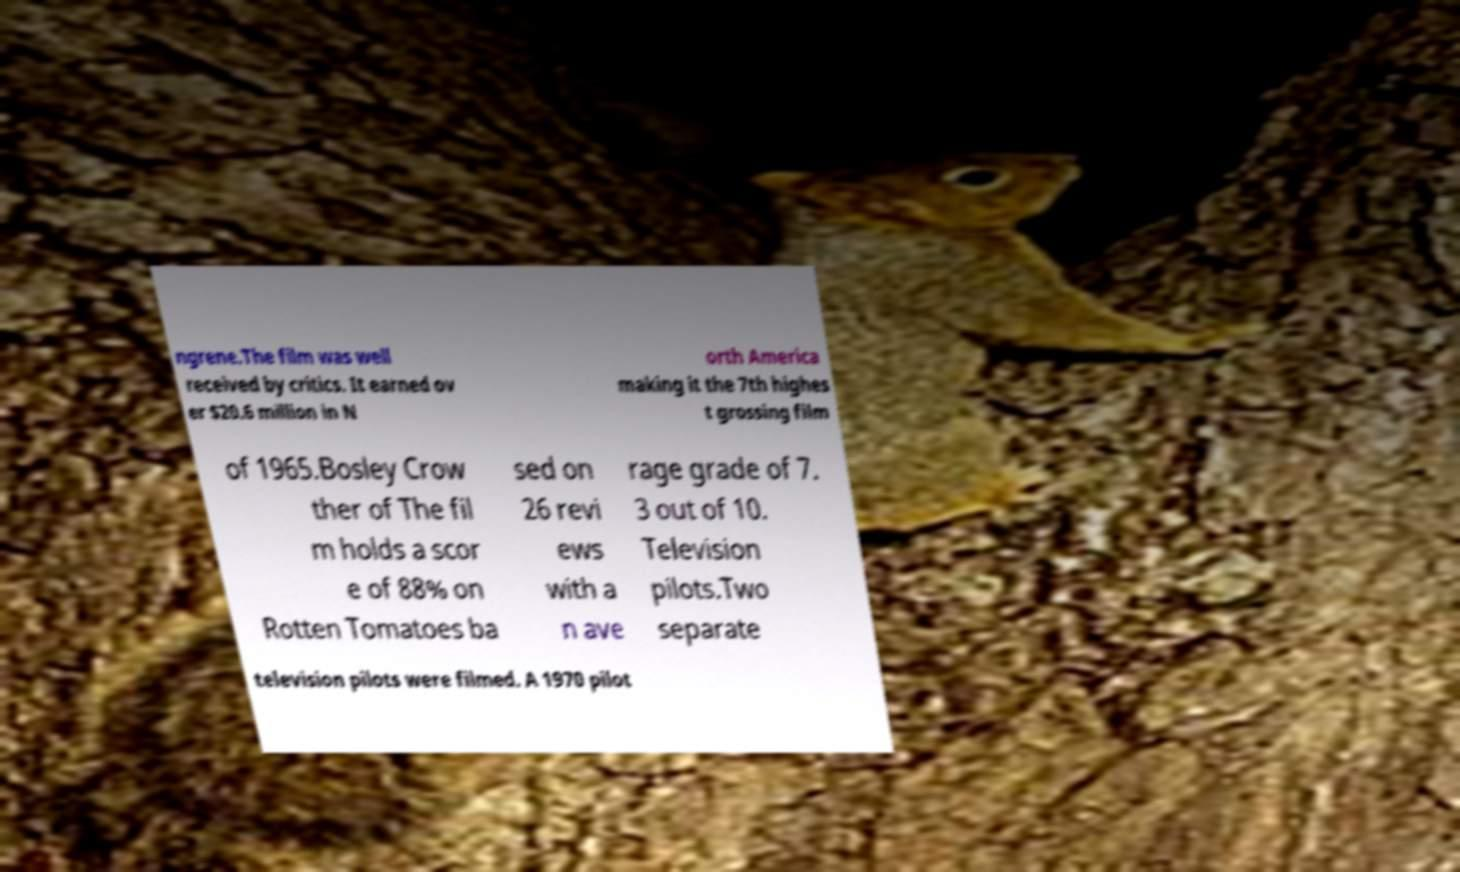There's text embedded in this image that I need extracted. Can you transcribe it verbatim? ngrene.The film was well received by critics. It earned ov er $20.6 million in N orth America making it the 7th highes t grossing film of 1965.Bosley Crow ther of The fil m holds a scor e of 88% on Rotten Tomatoes ba sed on 26 revi ews with a n ave rage grade of 7. 3 out of 10. Television pilots.Two separate television pilots were filmed. A 1970 pilot 